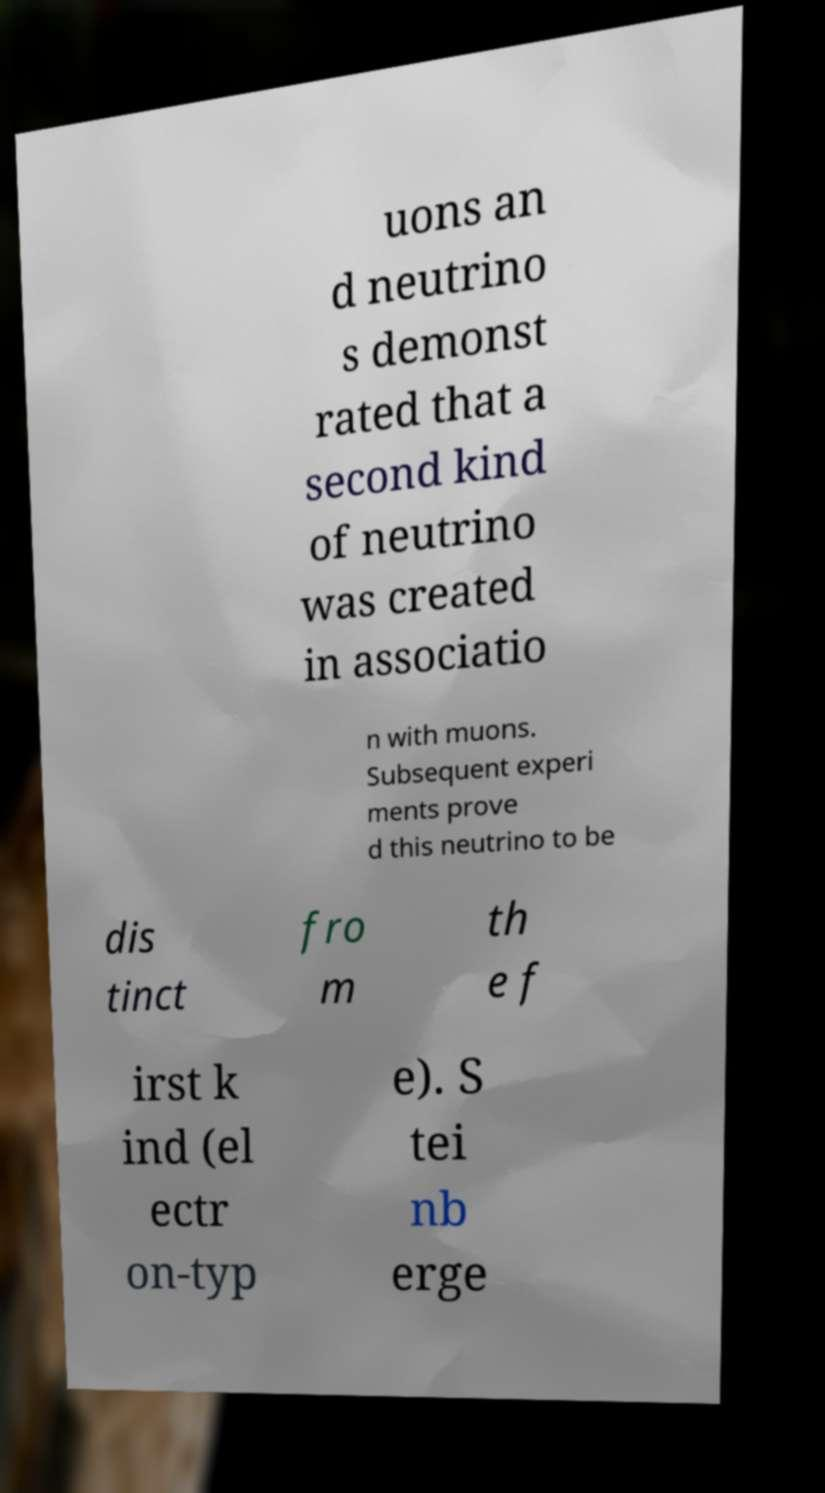There's text embedded in this image that I need extracted. Can you transcribe it verbatim? uons an d neutrino s demonst rated that a second kind of neutrino was created in associatio n with muons. Subsequent experi ments prove d this neutrino to be dis tinct fro m th e f irst k ind (el ectr on-typ e). S tei nb erge 